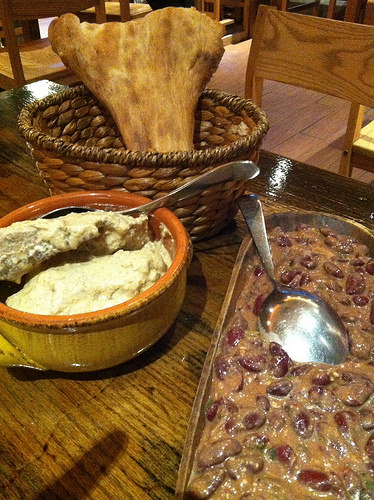<image>
Is the spoon in the tray? No. The spoon is not contained within the tray. These objects have a different spatial relationship. 